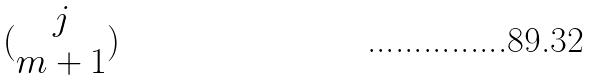Convert formula to latex. <formula><loc_0><loc_0><loc_500><loc_500>( \begin{matrix} j \\ m + 1 \end{matrix} )</formula> 